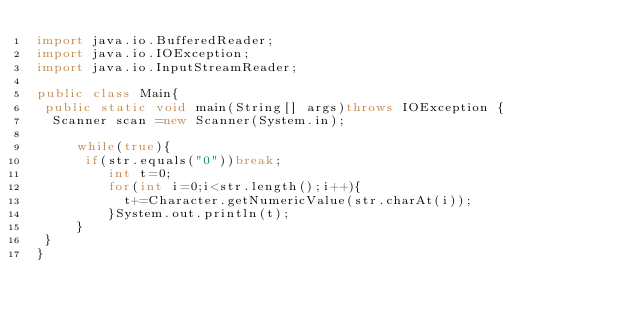<code> <loc_0><loc_0><loc_500><loc_500><_Java_>import java.io.BufferedReader;
import java.io.IOException;
import java.io.InputStreamReader;

public class Main{
 public static void main(String[] args)throws IOException {
  Scanner scan =new Scanner(System.in);
     
     while(true){
      if(str.equals("0"))break;
         int t=0;
         for(int i=0;i<str.length();i++){
           t+=Character.getNumericValue(str.charAt(i));
         }System.out.println(t);
     }
 }
}</code> 